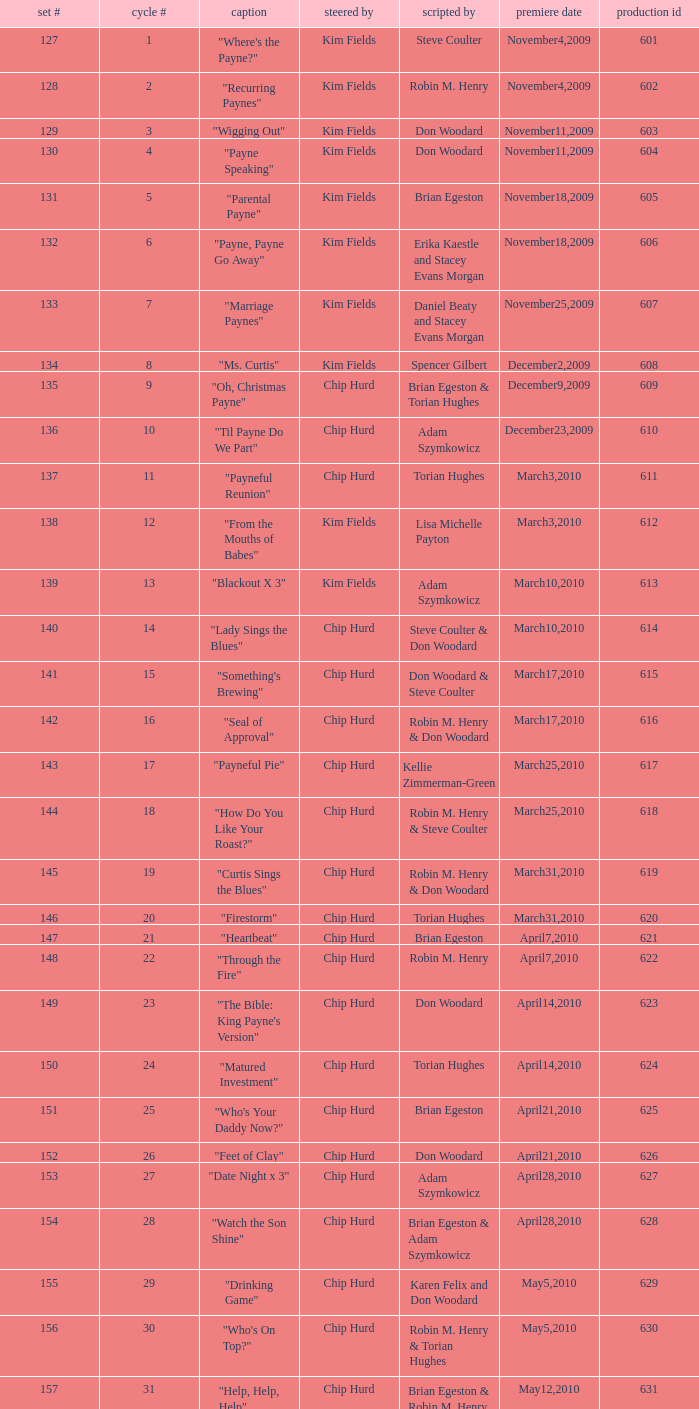What is the title of the episode with the production code 624? "Matured Investment". 